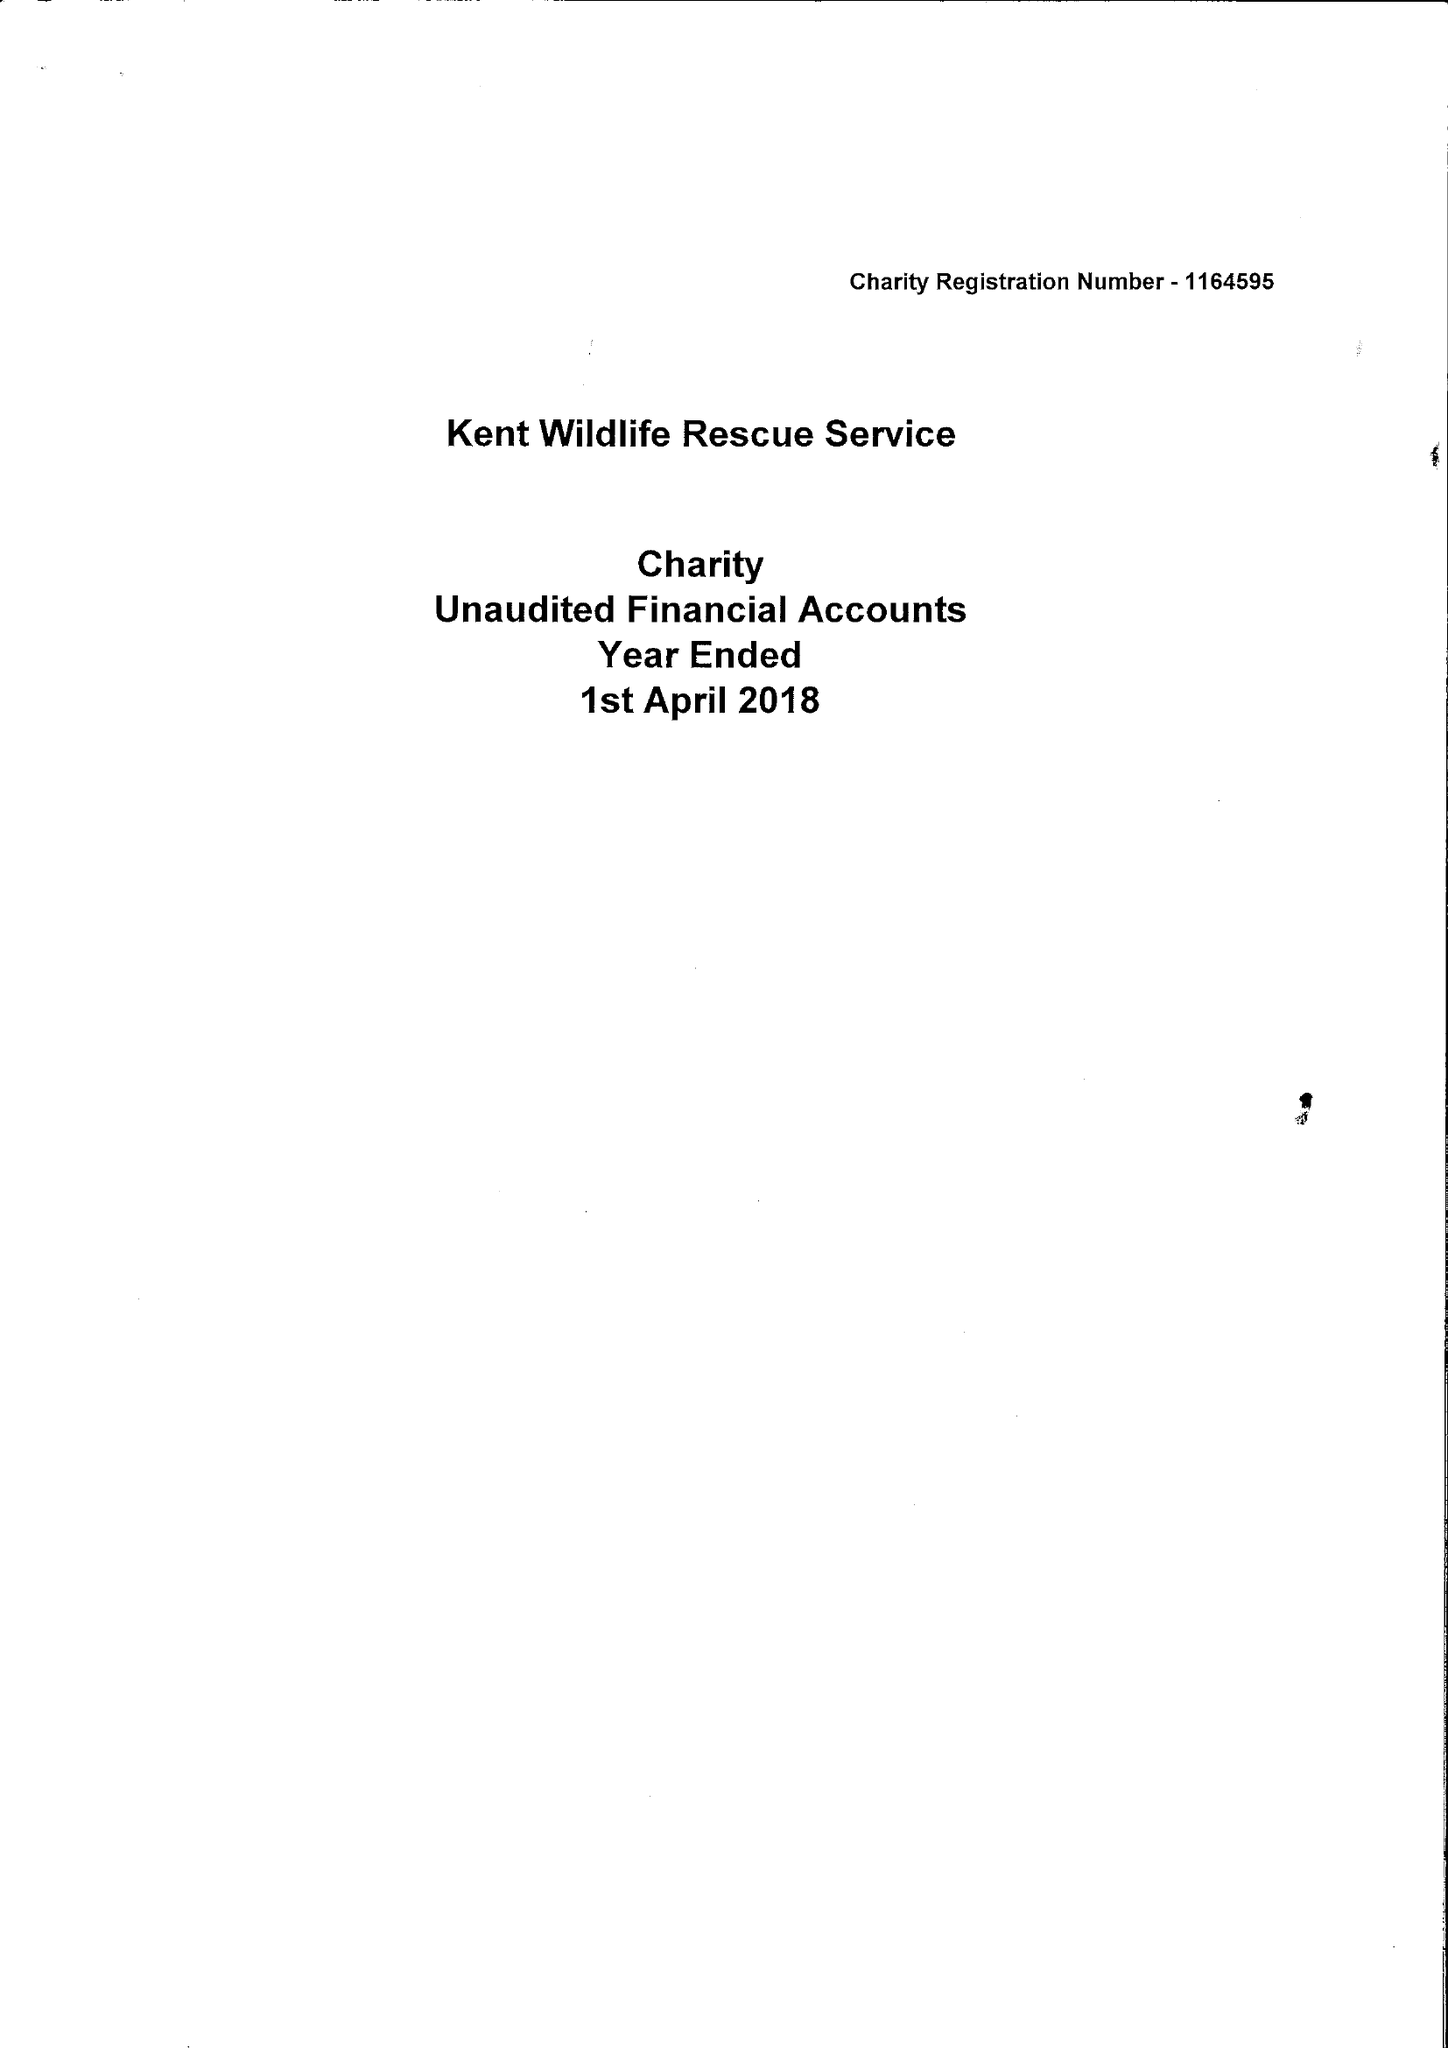What is the value for the address__post_town?
Answer the question using a single word or phrase. SHEERNESS 